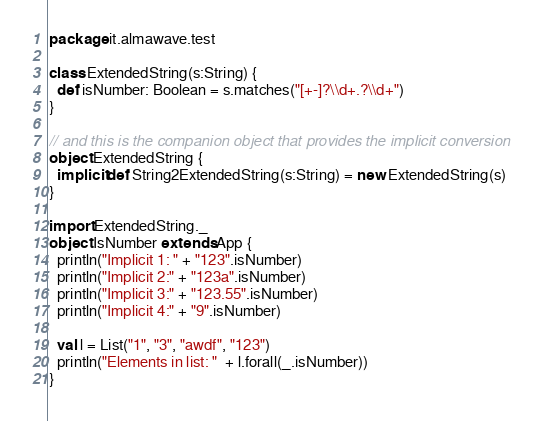<code> <loc_0><loc_0><loc_500><loc_500><_Scala_>package it.almawave.test

class ExtendedString(s:String) {
  def isNumber: Boolean = s.matches("[+-]?\\d+.?\\d+")
}

// and this is the companion object that provides the implicit conversion
object ExtendedString {
  implicit def String2ExtendedString(s:String) = new ExtendedString(s)
}

import ExtendedString._
object IsNumber extends App {
  println("Implicit 1: " + "123".isNumber)
  println("Implicit 2:" + "123a".isNumber)
  println("Implicit 3:" + "123.55".isNumber)
  println("Implicit 4:" + "9".isNumber)

  val l = List("1", "3", "awdf", "123")
  println("Elements in list: "  + l.forall(_.isNumber))
}
</code> 